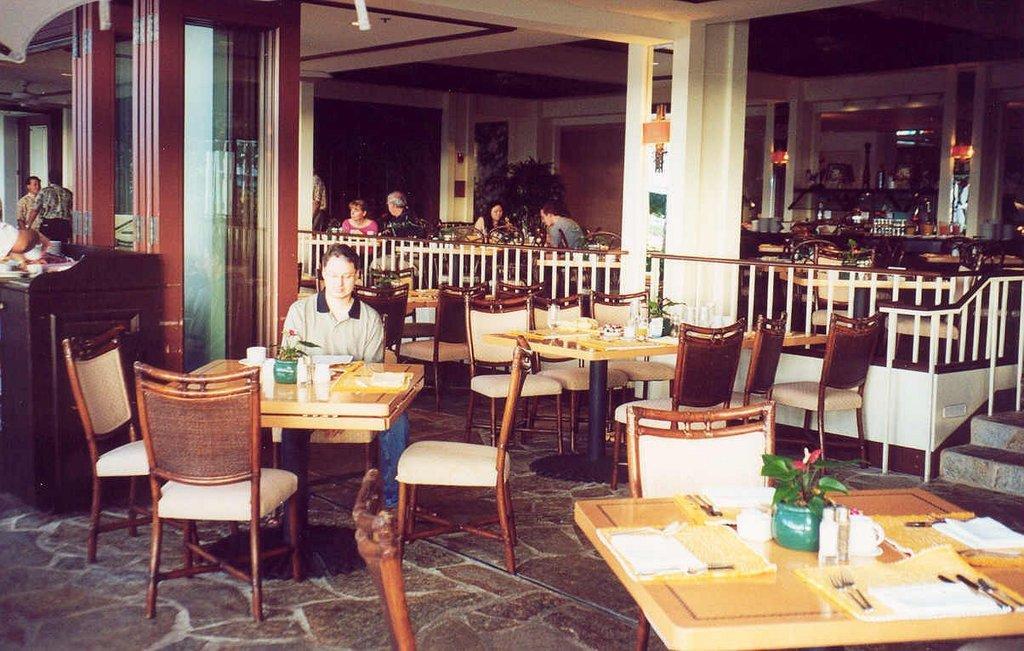Can you describe this image briefly? In this image, There are some tables which are in yellow color and there are some chairs in brown color and in the left side there is a man sitting on the chair, In the background there is a wall in white color and brown color wooden doors and there are some people sitting on the chairs around the table. 